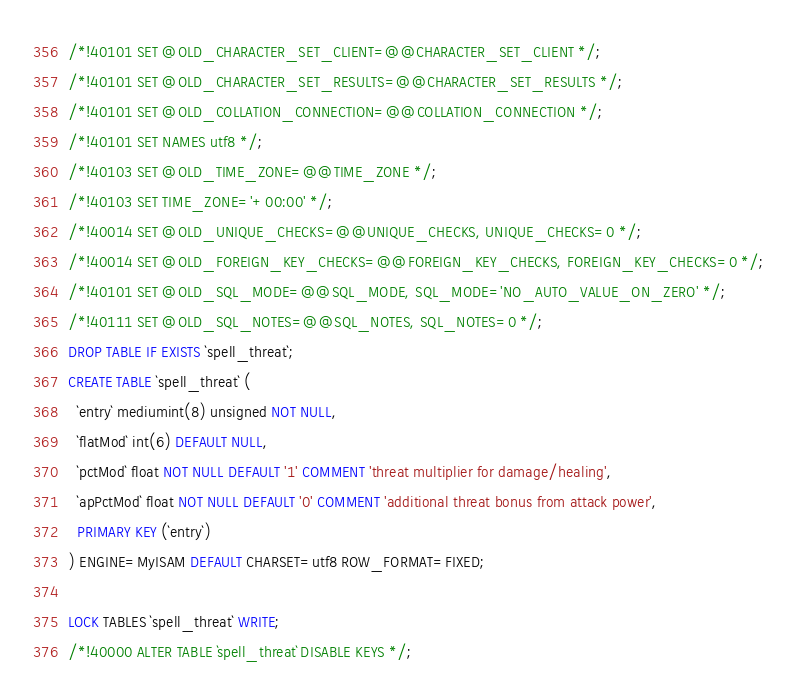Convert code to text. <code><loc_0><loc_0><loc_500><loc_500><_SQL_>
/*!40101 SET @OLD_CHARACTER_SET_CLIENT=@@CHARACTER_SET_CLIENT */;
/*!40101 SET @OLD_CHARACTER_SET_RESULTS=@@CHARACTER_SET_RESULTS */;
/*!40101 SET @OLD_COLLATION_CONNECTION=@@COLLATION_CONNECTION */;
/*!40101 SET NAMES utf8 */;
/*!40103 SET @OLD_TIME_ZONE=@@TIME_ZONE */;
/*!40103 SET TIME_ZONE='+00:00' */;
/*!40014 SET @OLD_UNIQUE_CHECKS=@@UNIQUE_CHECKS, UNIQUE_CHECKS=0 */;
/*!40014 SET @OLD_FOREIGN_KEY_CHECKS=@@FOREIGN_KEY_CHECKS, FOREIGN_KEY_CHECKS=0 */;
/*!40101 SET @OLD_SQL_MODE=@@SQL_MODE, SQL_MODE='NO_AUTO_VALUE_ON_ZERO' */;
/*!40111 SET @OLD_SQL_NOTES=@@SQL_NOTES, SQL_NOTES=0 */;
DROP TABLE IF EXISTS `spell_threat`;
CREATE TABLE `spell_threat` (
  `entry` mediumint(8) unsigned NOT NULL,
  `flatMod` int(6) DEFAULT NULL,
  `pctMod` float NOT NULL DEFAULT '1' COMMENT 'threat multiplier for damage/healing',
  `apPctMod` float NOT NULL DEFAULT '0' COMMENT 'additional threat bonus from attack power',
  PRIMARY KEY (`entry`)
) ENGINE=MyISAM DEFAULT CHARSET=utf8 ROW_FORMAT=FIXED;

LOCK TABLES `spell_threat` WRITE;
/*!40000 ALTER TABLE `spell_threat` DISABLE KEYS */;</code> 